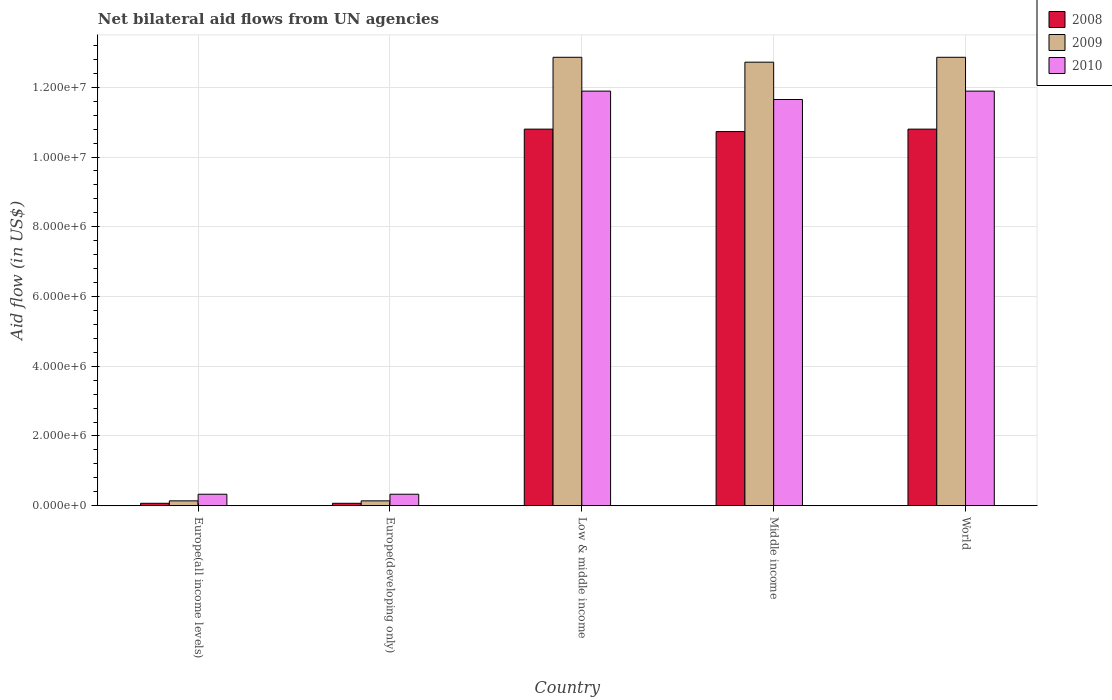How many different coloured bars are there?
Your answer should be compact. 3. Are the number of bars per tick equal to the number of legend labels?
Make the answer very short. Yes. Are the number of bars on each tick of the X-axis equal?
Provide a succinct answer. Yes. What is the label of the 3rd group of bars from the left?
Offer a very short reply. Low & middle income. In how many cases, is the number of bars for a given country not equal to the number of legend labels?
Your response must be concise. 0. What is the net bilateral aid flow in 2010 in World?
Make the answer very short. 1.19e+07. Across all countries, what is the maximum net bilateral aid flow in 2009?
Give a very brief answer. 1.29e+07. In which country was the net bilateral aid flow in 2010 maximum?
Ensure brevity in your answer.  Low & middle income. In which country was the net bilateral aid flow in 2009 minimum?
Give a very brief answer. Europe(all income levels). What is the total net bilateral aid flow in 2008 in the graph?
Your response must be concise. 3.25e+07. What is the difference between the net bilateral aid flow in 2010 in Europe(developing only) and that in Middle income?
Offer a very short reply. -1.13e+07. What is the difference between the net bilateral aid flow in 2010 in Low & middle income and the net bilateral aid flow in 2009 in Europe(all income levels)?
Make the answer very short. 1.18e+07. What is the average net bilateral aid flow in 2010 per country?
Your answer should be compact. 7.22e+06. What is the ratio of the net bilateral aid flow in 2008 in Low & middle income to that in Middle income?
Keep it short and to the point. 1.01. Is the difference between the net bilateral aid flow in 2009 in Middle income and World greater than the difference between the net bilateral aid flow in 2008 in Middle income and World?
Provide a short and direct response. No. What is the difference between the highest and the lowest net bilateral aid flow in 2008?
Offer a very short reply. 1.07e+07. In how many countries, is the net bilateral aid flow in 2009 greater than the average net bilateral aid flow in 2009 taken over all countries?
Provide a succinct answer. 3. What does the 3rd bar from the right in Low & middle income represents?
Your answer should be very brief. 2008. Is it the case that in every country, the sum of the net bilateral aid flow in 2008 and net bilateral aid flow in 2009 is greater than the net bilateral aid flow in 2010?
Keep it short and to the point. No. Are all the bars in the graph horizontal?
Your response must be concise. No. What is the difference between two consecutive major ticks on the Y-axis?
Give a very brief answer. 2.00e+06. Are the values on the major ticks of Y-axis written in scientific E-notation?
Your response must be concise. Yes. Does the graph contain any zero values?
Give a very brief answer. No. Does the graph contain grids?
Keep it short and to the point. Yes. Where does the legend appear in the graph?
Provide a succinct answer. Top right. How many legend labels are there?
Your response must be concise. 3. How are the legend labels stacked?
Your answer should be compact. Vertical. What is the title of the graph?
Ensure brevity in your answer.  Net bilateral aid flows from UN agencies. Does "1975" appear as one of the legend labels in the graph?
Your response must be concise. No. What is the label or title of the Y-axis?
Your response must be concise. Aid flow (in US$). What is the Aid flow (in US$) in 2010 in Europe(all income levels)?
Your answer should be very brief. 3.30e+05. What is the Aid flow (in US$) of 2009 in Europe(developing only)?
Provide a succinct answer. 1.40e+05. What is the Aid flow (in US$) of 2008 in Low & middle income?
Keep it short and to the point. 1.08e+07. What is the Aid flow (in US$) of 2009 in Low & middle income?
Provide a succinct answer. 1.29e+07. What is the Aid flow (in US$) of 2010 in Low & middle income?
Give a very brief answer. 1.19e+07. What is the Aid flow (in US$) of 2008 in Middle income?
Make the answer very short. 1.07e+07. What is the Aid flow (in US$) in 2009 in Middle income?
Provide a succinct answer. 1.27e+07. What is the Aid flow (in US$) in 2010 in Middle income?
Your answer should be very brief. 1.16e+07. What is the Aid flow (in US$) of 2008 in World?
Offer a very short reply. 1.08e+07. What is the Aid flow (in US$) in 2009 in World?
Your response must be concise. 1.29e+07. What is the Aid flow (in US$) in 2010 in World?
Your response must be concise. 1.19e+07. Across all countries, what is the maximum Aid flow (in US$) of 2008?
Ensure brevity in your answer.  1.08e+07. Across all countries, what is the maximum Aid flow (in US$) in 2009?
Your answer should be compact. 1.29e+07. Across all countries, what is the maximum Aid flow (in US$) of 2010?
Offer a very short reply. 1.19e+07. Across all countries, what is the minimum Aid flow (in US$) in 2009?
Provide a short and direct response. 1.40e+05. Across all countries, what is the minimum Aid flow (in US$) in 2010?
Provide a short and direct response. 3.30e+05. What is the total Aid flow (in US$) of 2008 in the graph?
Provide a succinct answer. 3.25e+07. What is the total Aid flow (in US$) in 2009 in the graph?
Offer a terse response. 3.87e+07. What is the total Aid flow (in US$) in 2010 in the graph?
Give a very brief answer. 3.61e+07. What is the difference between the Aid flow (in US$) of 2008 in Europe(all income levels) and that in Europe(developing only)?
Your answer should be very brief. 0. What is the difference between the Aid flow (in US$) of 2010 in Europe(all income levels) and that in Europe(developing only)?
Make the answer very short. 0. What is the difference between the Aid flow (in US$) in 2008 in Europe(all income levels) and that in Low & middle income?
Offer a very short reply. -1.07e+07. What is the difference between the Aid flow (in US$) of 2009 in Europe(all income levels) and that in Low & middle income?
Provide a succinct answer. -1.27e+07. What is the difference between the Aid flow (in US$) of 2010 in Europe(all income levels) and that in Low & middle income?
Give a very brief answer. -1.16e+07. What is the difference between the Aid flow (in US$) in 2008 in Europe(all income levels) and that in Middle income?
Provide a succinct answer. -1.07e+07. What is the difference between the Aid flow (in US$) of 2009 in Europe(all income levels) and that in Middle income?
Offer a very short reply. -1.26e+07. What is the difference between the Aid flow (in US$) in 2010 in Europe(all income levels) and that in Middle income?
Make the answer very short. -1.13e+07. What is the difference between the Aid flow (in US$) of 2008 in Europe(all income levels) and that in World?
Provide a short and direct response. -1.07e+07. What is the difference between the Aid flow (in US$) in 2009 in Europe(all income levels) and that in World?
Your answer should be very brief. -1.27e+07. What is the difference between the Aid flow (in US$) of 2010 in Europe(all income levels) and that in World?
Make the answer very short. -1.16e+07. What is the difference between the Aid flow (in US$) of 2008 in Europe(developing only) and that in Low & middle income?
Offer a terse response. -1.07e+07. What is the difference between the Aid flow (in US$) in 2009 in Europe(developing only) and that in Low & middle income?
Keep it short and to the point. -1.27e+07. What is the difference between the Aid flow (in US$) in 2010 in Europe(developing only) and that in Low & middle income?
Your answer should be very brief. -1.16e+07. What is the difference between the Aid flow (in US$) of 2008 in Europe(developing only) and that in Middle income?
Make the answer very short. -1.07e+07. What is the difference between the Aid flow (in US$) of 2009 in Europe(developing only) and that in Middle income?
Give a very brief answer. -1.26e+07. What is the difference between the Aid flow (in US$) in 2010 in Europe(developing only) and that in Middle income?
Make the answer very short. -1.13e+07. What is the difference between the Aid flow (in US$) in 2008 in Europe(developing only) and that in World?
Offer a terse response. -1.07e+07. What is the difference between the Aid flow (in US$) of 2009 in Europe(developing only) and that in World?
Keep it short and to the point. -1.27e+07. What is the difference between the Aid flow (in US$) of 2010 in Europe(developing only) and that in World?
Give a very brief answer. -1.16e+07. What is the difference between the Aid flow (in US$) in 2009 in Low & middle income and that in Middle income?
Keep it short and to the point. 1.40e+05. What is the difference between the Aid flow (in US$) of 2010 in Low & middle income and that in Middle income?
Your answer should be very brief. 2.40e+05. What is the difference between the Aid flow (in US$) of 2009 in Middle income and that in World?
Offer a terse response. -1.40e+05. What is the difference between the Aid flow (in US$) of 2010 in Middle income and that in World?
Ensure brevity in your answer.  -2.40e+05. What is the difference between the Aid flow (in US$) of 2008 in Europe(all income levels) and the Aid flow (in US$) of 2009 in Europe(developing only)?
Provide a short and direct response. -7.00e+04. What is the difference between the Aid flow (in US$) in 2008 in Europe(all income levels) and the Aid flow (in US$) in 2009 in Low & middle income?
Offer a terse response. -1.28e+07. What is the difference between the Aid flow (in US$) of 2008 in Europe(all income levels) and the Aid flow (in US$) of 2010 in Low & middle income?
Provide a short and direct response. -1.18e+07. What is the difference between the Aid flow (in US$) in 2009 in Europe(all income levels) and the Aid flow (in US$) in 2010 in Low & middle income?
Offer a terse response. -1.18e+07. What is the difference between the Aid flow (in US$) in 2008 in Europe(all income levels) and the Aid flow (in US$) in 2009 in Middle income?
Your answer should be compact. -1.26e+07. What is the difference between the Aid flow (in US$) of 2008 in Europe(all income levels) and the Aid flow (in US$) of 2010 in Middle income?
Offer a terse response. -1.16e+07. What is the difference between the Aid flow (in US$) in 2009 in Europe(all income levels) and the Aid flow (in US$) in 2010 in Middle income?
Offer a terse response. -1.15e+07. What is the difference between the Aid flow (in US$) in 2008 in Europe(all income levels) and the Aid flow (in US$) in 2009 in World?
Give a very brief answer. -1.28e+07. What is the difference between the Aid flow (in US$) of 2008 in Europe(all income levels) and the Aid flow (in US$) of 2010 in World?
Provide a short and direct response. -1.18e+07. What is the difference between the Aid flow (in US$) of 2009 in Europe(all income levels) and the Aid flow (in US$) of 2010 in World?
Offer a terse response. -1.18e+07. What is the difference between the Aid flow (in US$) of 2008 in Europe(developing only) and the Aid flow (in US$) of 2009 in Low & middle income?
Provide a short and direct response. -1.28e+07. What is the difference between the Aid flow (in US$) of 2008 in Europe(developing only) and the Aid flow (in US$) of 2010 in Low & middle income?
Give a very brief answer. -1.18e+07. What is the difference between the Aid flow (in US$) in 2009 in Europe(developing only) and the Aid flow (in US$) in 2010 in Low & middle income?
Provide a short and direct response. -1.18e+07. What is the difference between the Aid flow (in US$) in 2008 in Europe(developing only) and the Aid flow (in US$) in 2009 in Middle income?
Make the answer very short. -1.26e+07. What is the difference between the Aid flow (in US$) in 2008 in Europe(developing only) and the Aid flow (in US$) in 2010 in Middle income?
Your answer should be very brief. -1.16e+07. What is the difference between the Aid flow (in US$) of 2009 in Europe(developing only) and the Aid flow (in US$) of 2010 in Middle income?
Offer a very short reply. -1.15e+07. What is the difference between the Aid flow (in US$) of 2008 in Europe(developing only) and the Aid flow (in US$) of 2009 in World?
Your answer should be very brief. -1.28e+07. What is the difference between the Aid flow (in US$) in 2008 in Europe(developing only) and the Aid flow (in US$) in 2010 in World?
Offer a very short reply. -1.18e+07. What is the difference between the Aid flow (in US$) of 2009 in Europe(developing only) and the Aid flow (in US$) of 2010 in World?
Offer a terse response. -1.18e+07. What is the difference between the Aid flow (in US$) of 2008 in Low & middle income and the Aid flow (in US$) of 2009 in Middle income?
Keep it short and to the point. -1.92e+06. What is the difference between the Aid flow (in US$) in 2008 in Low & middle income and the Aid flow (in US$) in 2010 in Middle income?
Your answer should be compact. -8.50e+05. What is the difference between the Aid flow (in US$) in 2009 in Low & middle income and the Aid flow (in US$) in 2010 in Middle income?
Your answer should be very brief. 1.21e+06. What is the difference between the Aid flow (in US$) of 2008 in Low & middle income and the Aid flow (in US$) of 2009 in World?
Keep it short and to the point. -2.06e+06. What is the difference between the Aid flow (in US$) in 2008 in Low & middle income and the Aid flow (in US$) in 2010 in World?
Your response must be concise. -1.09e+06. What is the difference between the Aid flow (in US$) in 2009 in Low & middle income and the Aid flow (in US$) in 2010 in World?
Ensure brevity in your answer.  9.70e+05. What is the difference between the Aid flow (in US$) of 2008 in Middle income and the Aid flow (in US$) of 2009 in World?
Give a very brief answer. -2.13e+06. What is the difference between the Aid flow (in US$) of 2008 in Middle income and the Aid flow (in US$) of 2010 in World?
Provide a succinct answer. -1.16e+06. What is the difference between the Aid flow (in US$) of 2009 in Middle income and the Aid flow (in US$) of 2010 in World?
Make the answer very short. 8.30e+05. What is the average Aid flow (in US$) in 2008 per country?
Ensure brevity in your answer.  6.49e+06. What is the average Aid flow (in US$) of 2009 per country?
Offer a terse response. 7.74e+06. What is the average Aid flow (in US$) of 2010 per country?
Your answer should be compact. 7.22e+06. What is the difference between the Aid flow (in US$) in 2008 and Aid flow (in US$) in 2010 in Europe(all income levels)?
Give a very brief answer. -2.60e+05. What is the difference between the Aid flow (in US$) in 2009 and Aid flow (in US$) in 2010 in Europe(developing only)?
Offer a terse response. -1.90e+05. What is the difference between the Aid flow (in US$) of 2008 and Aid flow (in US$) of 2009 in Low & middle income?
Provide a succinct answer. -2.06e+06. What is the difference between the Aid flow (in US$) of 2008 and Aid flow (in US$) of 2010 in Low & middle income?
Ensure brevity in your answer.  -1.09e+06. What is the difference between the Aid flow (in US$) of 2009 and Aid flow (in US$) of 2010 in Low & middle income?
Offer a very short reply. 9.70e+05. What is the difference between the Aid flow (in US$) of 2008 and Aid flow (in US$) of 2009 in Middle income?
Make the answer very short. -1.99e+06. What is the difference between the Aid flow (in US$) in 2008 and Aid flow (in US$) in 2010 in Middle income?
Your answer should be very brief. -9.20e+05. What is the difference between the Aid flow (in US$) of 2009 and Aid flow (in US$) of 2010 in Middle income?
Your response must be concise. 1.07e+06. What is the difference between the Aid flow (in US$) of 2008 and Aid flow (in US$) of 2009 in World?
Make the answer very short. -2.06e+06. What is the difference between the Aid flow (in US$) in 2008 and Aid flow (in US$) in 2010 in World?
Make the answer very short. -1.09e+06. What is the difference between the Aid flow (in US$) of 2009 and Aid flow (in US$) of 2010 in World?
Ensure brevity in your answer.  9.70e+05. What is the ratio of the Aid flow (in US$) in 2009 in Europe(all income levels) to that in Europe(developing only)?
Make the answer very short. 1. What is the ratio of the Aid flow (in US$) of 2008 in Europe(all income levels) to that in Low & middle income?
Make the answer very short. 0.01. What is the ratio of the Aid flow (in US$) of 2009 in Europe(all income levels) to that in Low & middle income?
Keep it short and to the point. 0.01. What is the ratio of the Aid flow (in US$) of 2010 in Europe(all income levels) to that in Low & middle income?
Your response must be concise. 0.03. What is the ratio of the Aid flow (in US$) of 2008 in Europe(all income levels) to that in Middle income?
Offer a terse response. 0.01. What is the ratio of the Aid flow (in US$) in 2009 in Europe(all income levels) to that in Middle income?
Keep it short and to the point. 0.01. What is the ratio of the Aid flow (in US$) in 2010 in Europe(all income levels) to that in Middle income?
Ensure brevity in your answer.  0.03. What is the ratio of the Aid flow (in US$) of 2008 in Europe(all income levels) to that in World?
Give a very brief answer. 0.01. What is the ratio of the Aid flow (in US$) of 2009 in Europe(all income levels) to that in World?
Ensure brevity in your answer.  0.01. What is the ratio of the Aid flow (in US$) of 2010 in Europe(all income levels) to that in World?
Ensure brevity in your answer.  0.03. What is the ratio of the Aid flow (in US$) in 2008 in Europe(developing only) to that in Low & middle income?
Provide a succinct answer. 0.01. What is the ratio of the Aid flow (in US$) in 2009 in Europe(developing only) to that in Low & middle income?
Make the answer very short. 0.01. What is the ratio of the Aid flow (in US$) in 2010 in Europe(developing only) to that in Low & middle income?
Ensure brevity in your answer.  0.03. What is the ratio of the Aid flow (in US$) in 2008 in Europe(developing only) to that in Middle income?
Give a very brief answer. 0.01. What is the ratio of the Aid flow (in US$) in 2009 in Europe(developing only) to that in Middle income?
Your answer should be very brief. 0.01. What is the ratio of the Aid flow (in US$) of 2010 in Europe(developing only) to that in Middle income?
Your answer should be compact. 0.03. What is the ratio of the Aid flow (in US$) in 2008 in Europe(developing only) to that in World?
Keep it short and to the point. 0.01. What is the ratio of the Aid flow (in US$) in 2009 in Europe(developing only) to that in World?
Your response must be concise. 0.01. What is the ratio of the Aid flow (in US$) in 2010 in Europe(developing only) to that in World?
Provide a succinct answer. 0.03. What is the ratio of the Aid flow (in US$) of 2009 in Low & middle income to that in Middle income?
Offer a very short reply. 1.01. What is the ratio of the Aid flow (in US$) of 2010 in Low & middle income to that in Middle income?
Keep it short and to the point. 1.02. What is the ratio of the Aid flow (in US$) in 2009 in Low & middle income to that in World?
Give a very brief answer. 1. What is the ratio of the Aid flow (in US$) in 2010 in Low & middle income to that in World?
Your answer should be very brief. 1. What is the ratio of the Aid flow (in US$) in 2010 in Middle income to that in World?
Ensure brevity in your answer.  0.98. What is the difference between the highest and the second highest Aid flow (in US$) in 2009?
Provide a short and direct response. 0. What is the difference between the highest and the lowest Aid flow (in US$) of 2008?
Offer a terse response. 1.07e+07. What is the difference between the highest and the lowest Aid flow (in US$) in 2009?
Give a very brief answer. 1.27e+07. What is the difference between the highest and the lowest Aid flow (in US$) of 2010?
Your answer should be very brief. 1.16e+07. 